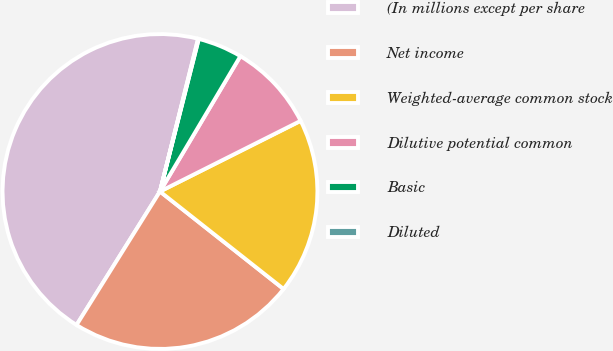<chart> <loc_0><loc_0><loc_500><loc_500><pie_chart><fcel>(In millions except per share<fcel>Net income<fcel>Weighted-average common stock<fcel>Dilutive potential common<fcel>Basic<fcel>Diluted<nl><fcel>45.0%<fcel>23.26%<fcel>18.04%<fcel>9.06%<fcel>4.57%<fcel>0.07%<nl></chart> 